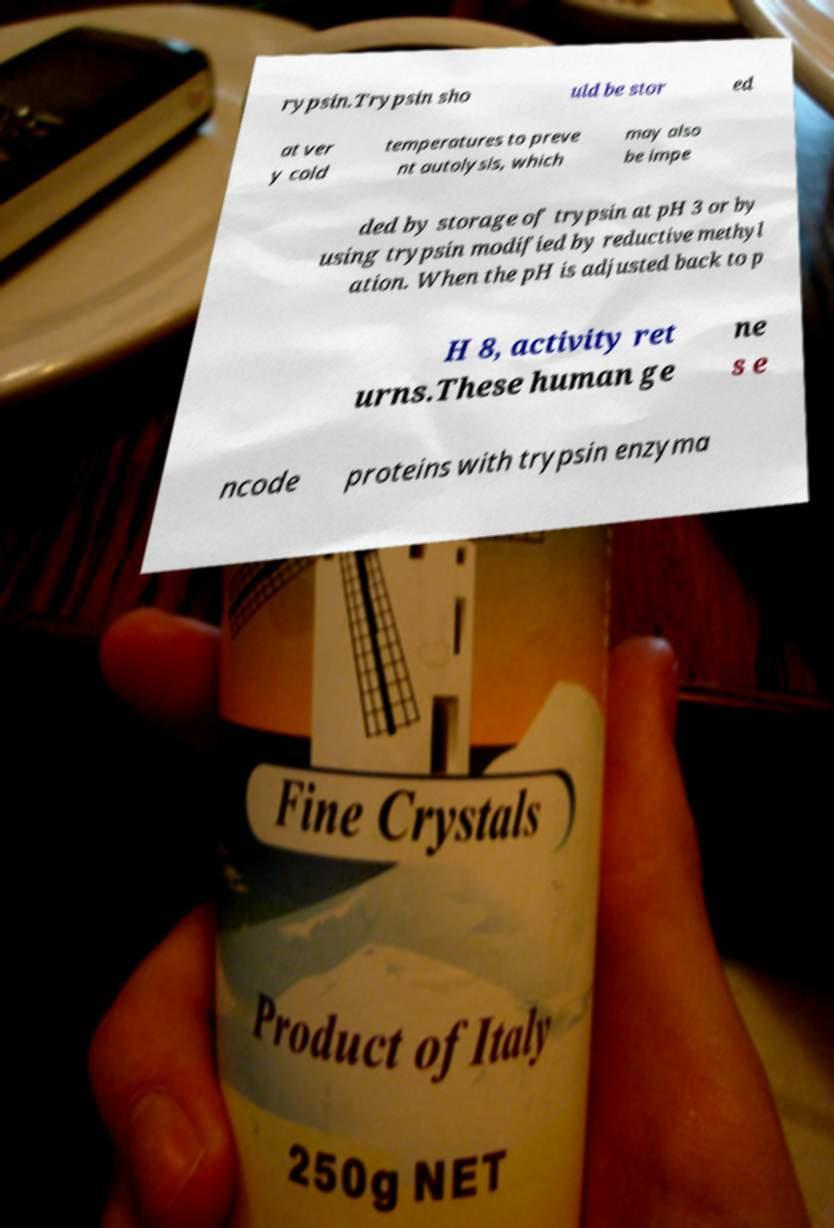Please identify and transcribe the text found in this image. rypsin.Trypsin sho uld be stor ed at ver y cold temperatures to preve nt autolysis, which may also be impe ded by storage of trypsin at pH 3 or by using trypsin modified by reductive methyl ation. When the pH is adjusted back to p H 8, activity ret urns.These human ge ne s e ncode proteins with trypsin enzyma 